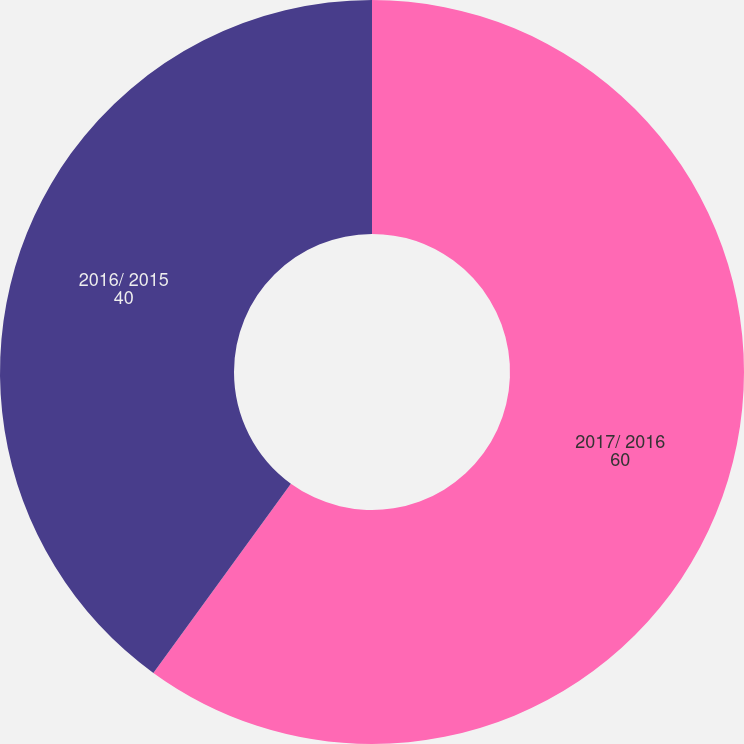Convert chart. <chart><loc_0><loc_0><loc_500><loc_500><pie_chart><fcel>2017/ 2016<fcel>2016/ 2015<nl><fcel>60.0%<fcel>40.0%<nl></chart> 